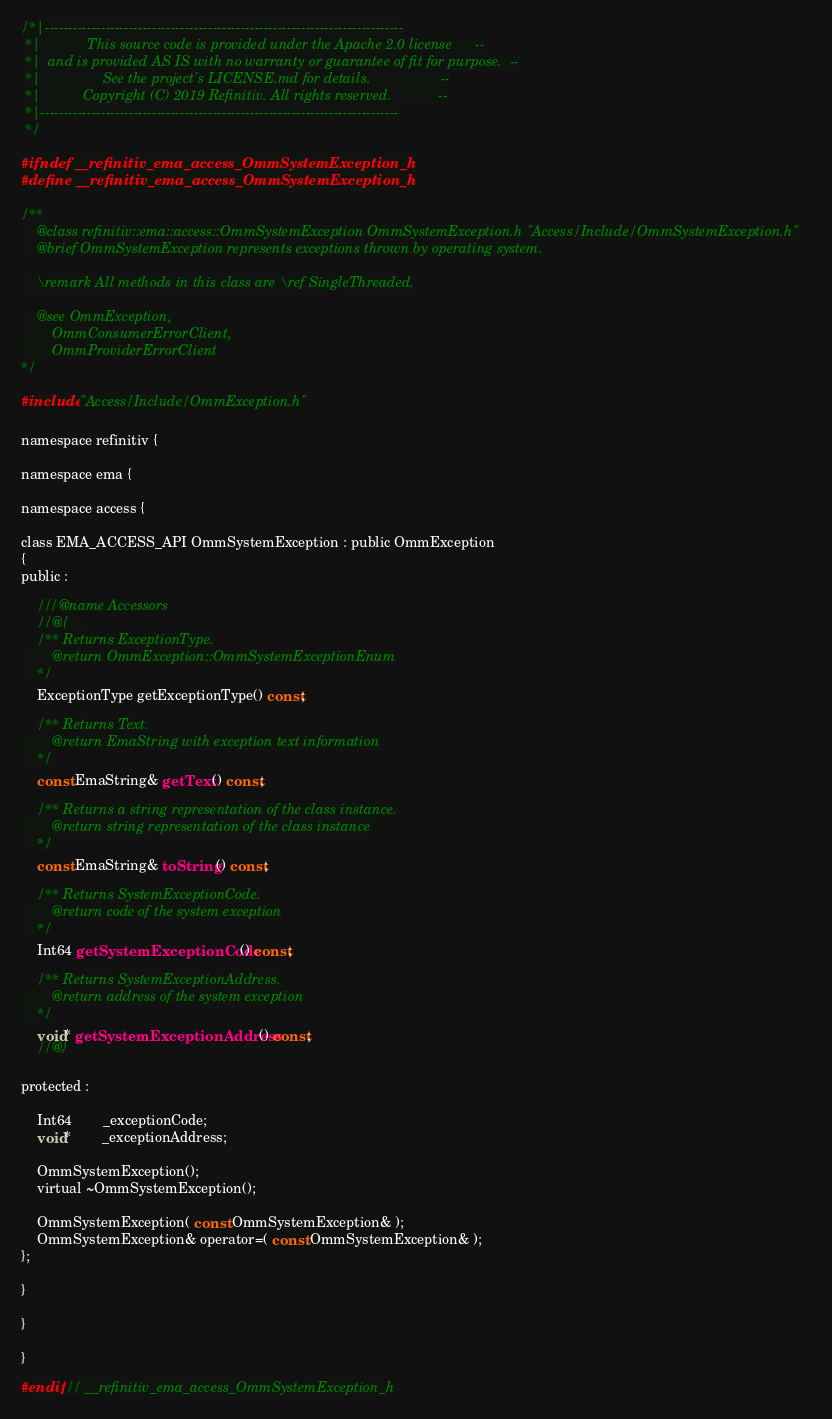<code> <loc_0><loc_0><loc_500><loc_500><_C_>/*|-----------------------------------------------------------------------------
 *|            This source code is provided under the Apache 2.0 license      --
 *|  and is provided AS IS with no warranty or guarantee of fit for purpose.  --
 *|                See the project's LICENSE.md for details.                  --
 *|           Copyright (C) 2019 Refinitiv. All rights reserved.            --
 *|-----------------------------------------------------------------------------
 */

#ifndef __refinitiv_ema_access_OmmSystemException_h
#define __refinitiv_ema_access_OmmSystemException_h

/**
	@class refinitiv::ema::access::OmmSystemException OmmSystemException.h "Access/Include/OmmSystemException.h"
	@brief OmmSystemException represents exceptions thrown by operating system.

	\remark All methods in this class are \ref SingleThreaded.

	@see OmmException,
		OmmConsumerErrorClient,
		OmmProviderErrorClient
*/

#include "Access/Include/OmmException.h"

namespace refinitiv {

namespace ema {

namespace access {

class EMA_ACCESS_API OmmSystemException : public OmmException
{
public :

	///@name Accessors
	//@{	
	/** Returns ExceptionType.
		@return OmmException::OmmSystemExceptionEnum
	*/
	ExceptionType getExceptionType() const;

	/** Returns Text.
		@return EmaString with exception text information
	*/
	const EmaString& getText() const;

	/** Returns a string representation of the class instance.
		@return string representation of the class instance
	*/
	const EmaString& toString() const;

	/** Returns SystemExceptionCode.
		@return code of the system exception
	*/
	Int64 getSystemExceptionCode() const;

	/** Returns SystemExceptionAddress.
		@return address of the system exception
	*/
	void* getSystemExceptionAddress() const;
	//@}

protected :

	Int64		_exceptionCode;
	void*		_exceptionAddress;

	OmmSystemException();
	virtual ~OmmSystemException();

	OmmSystemException( const OmmSystemException& );
	OmmSystemException& operator=( const OmmSystemException& );
};

}

}

}

#endif // __refinitiv_ema_access_OmmSystemException_h
</code> 